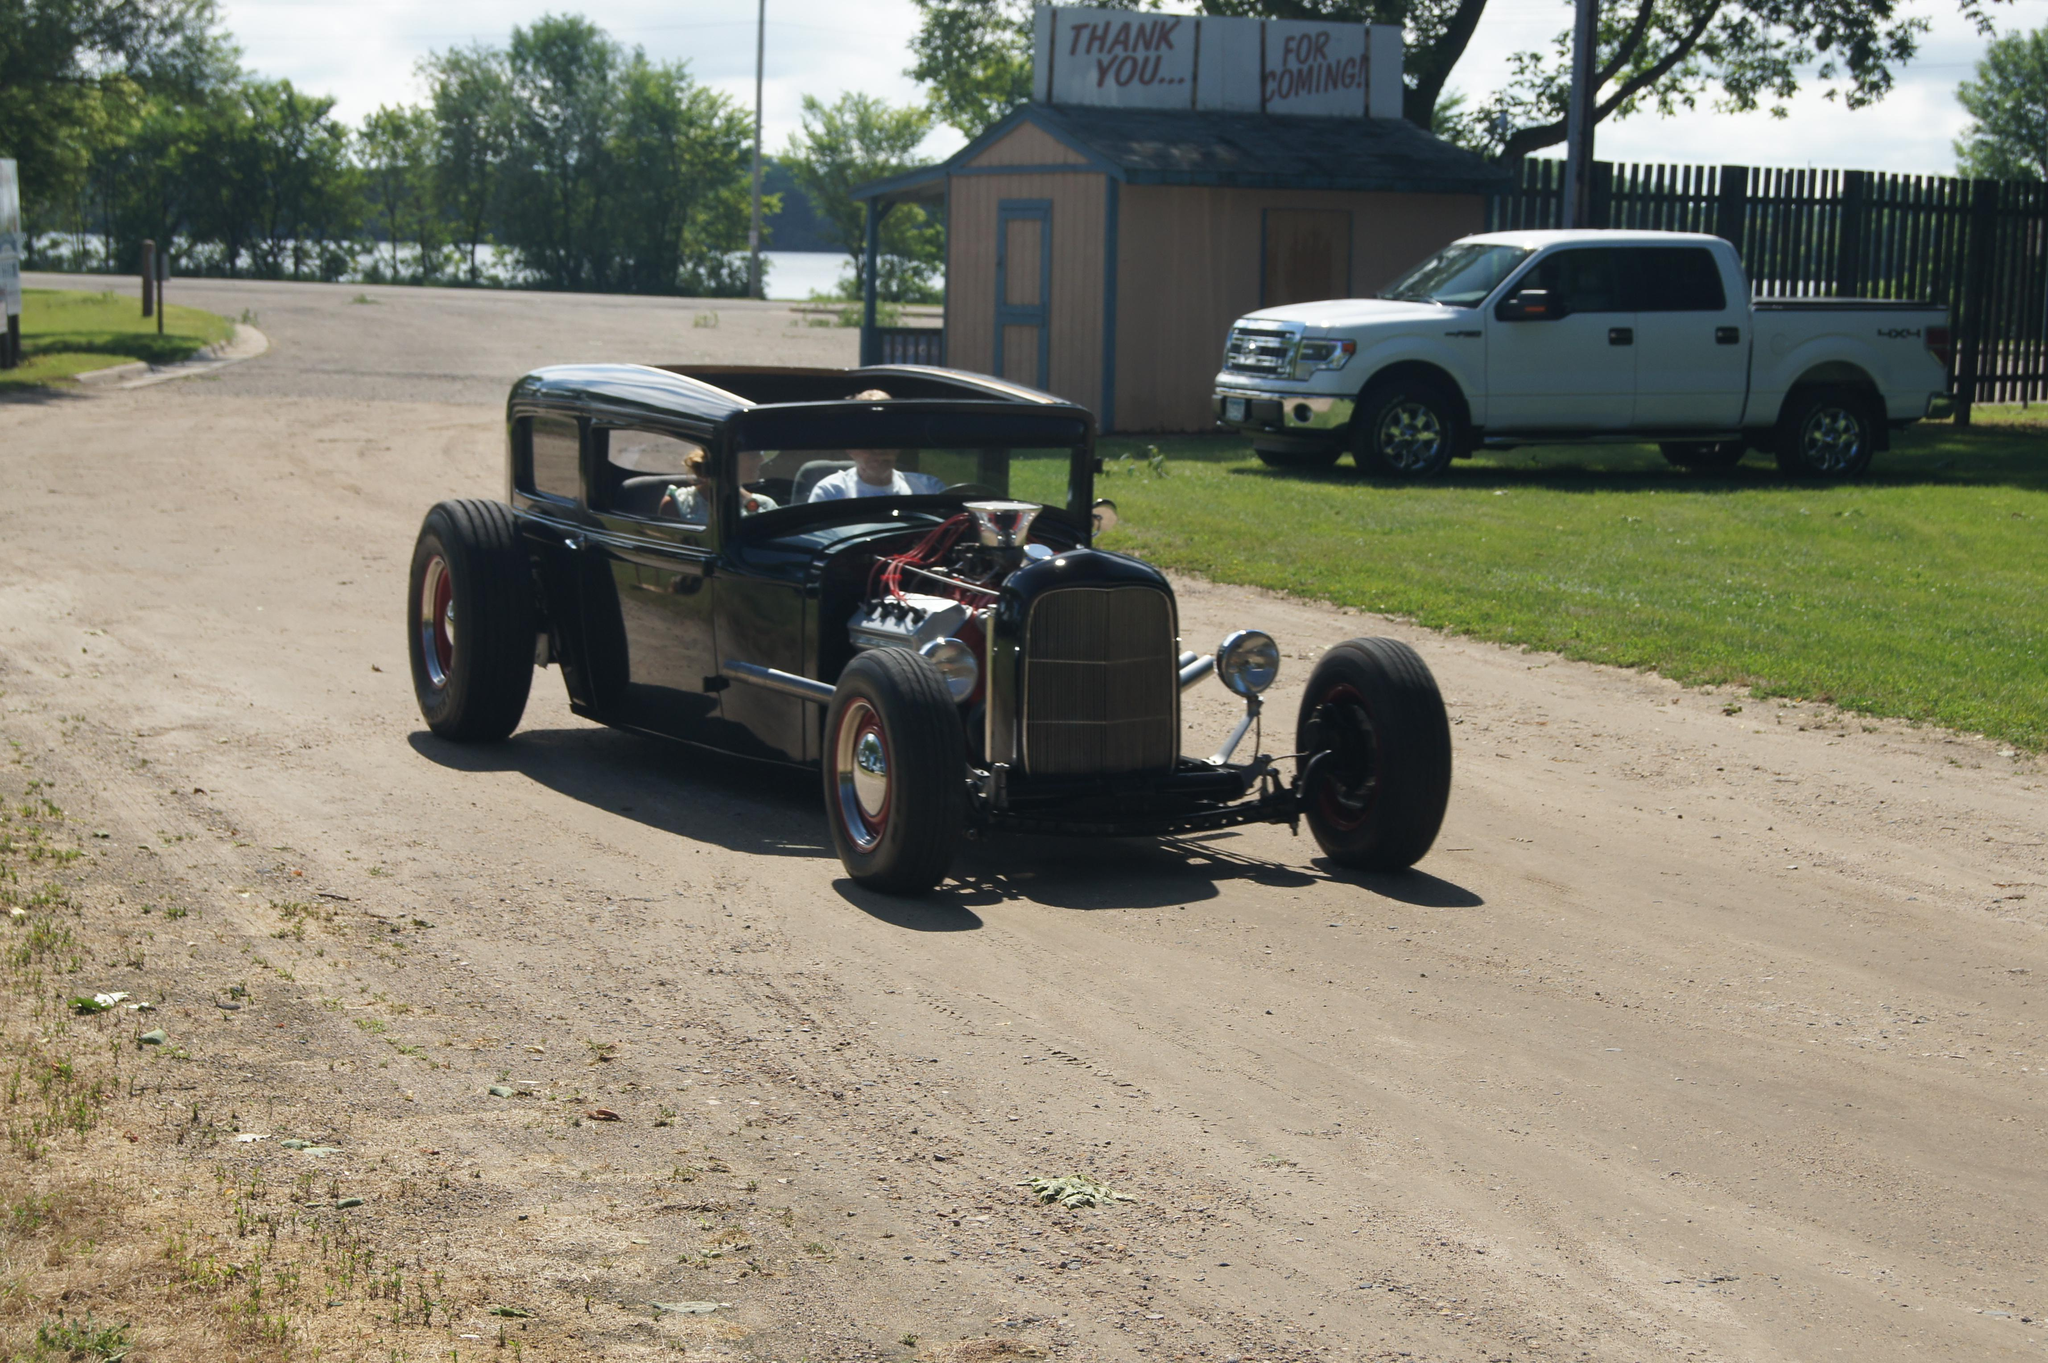What are the two people doing in the image? The two people are riding a vehicle on the road. What can be seen in the background of the image? There is a shed, fencing, a truck, trees, grass, a pole, a hoarding, and the sky visible in the background. What type of disease is being treated in the image? There is no indication of a disease or any medical treatment in the image. Which direction are the people facing in the image? The image does not provide information about the direction the people are facing, only that they are riding a vehicle on the road. 